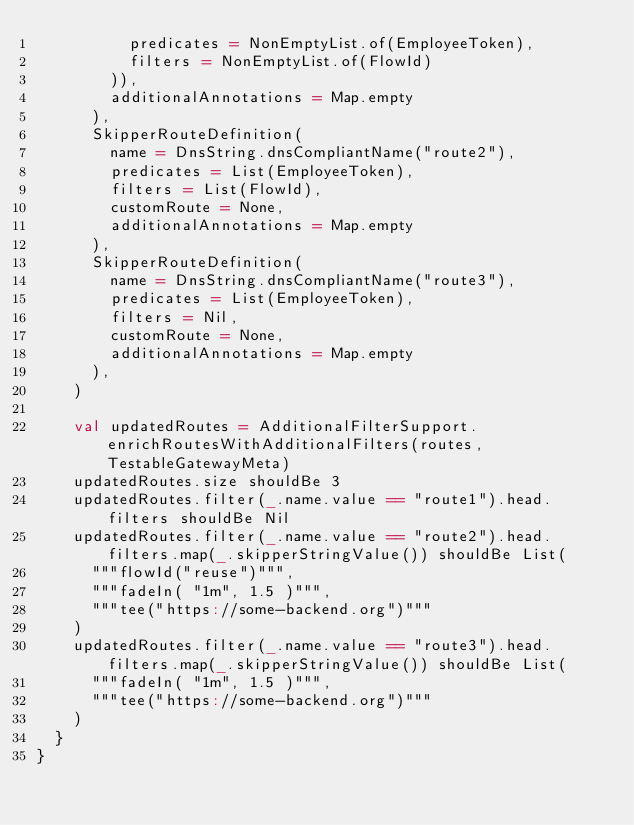<code> <loc_0><loc_0><loc_500><loc_500><_Scala_>          predicates = NonEmptyList.of(EmployeeToken),
          filters = NonEmptyList.of(FlowId)
        )),
        additionalAnnotations = Map.empty
      ),
      SkipperRouteDefinition(
        name = DnsString.dnsCompliantName("route2"),
        predicates = List(EmployeeToken),
        filters = List(FlowId),
        customRoute = None,
        additionalAnnotations = Map.empty
      ),
      SkipperRouteDefinition(
        name = DnsString.dnsCompliantName("route3"),
        predicates = List(EmployeeToken),
        filters = Nil,
        customRoute = None,
        additionalAnnotations = Map.empty
      ),
    )

    val updatedRoutes = AdditionalFilterSupport.enrichRoutesWithAdditionalFilters(routes, TestableGatewayMeta)
    updatedRoutes.size shouldBe 3
    updatedRoutes.filter(_.name.value == "route1").head.filters shouldBe Nil
    updatedRoutes.filter(_.name.value == "route2").head.filters.map(_.skipperStringValue()) shouldBe List(
      """flowId("reuse")""",
      """fadeIn( "1m", 1.5 )""",
      """tee("https://some-backend.org")"""
    )
    updatedRoutes.filter(_.name.value == "route3").head.filters.map(_.skipperStringValue()) shouldBe List(
      """fadeIn( "1m", 1.5 )""",
      """tee("https://some-backend.org")"""
    )
  }
}
</code> 